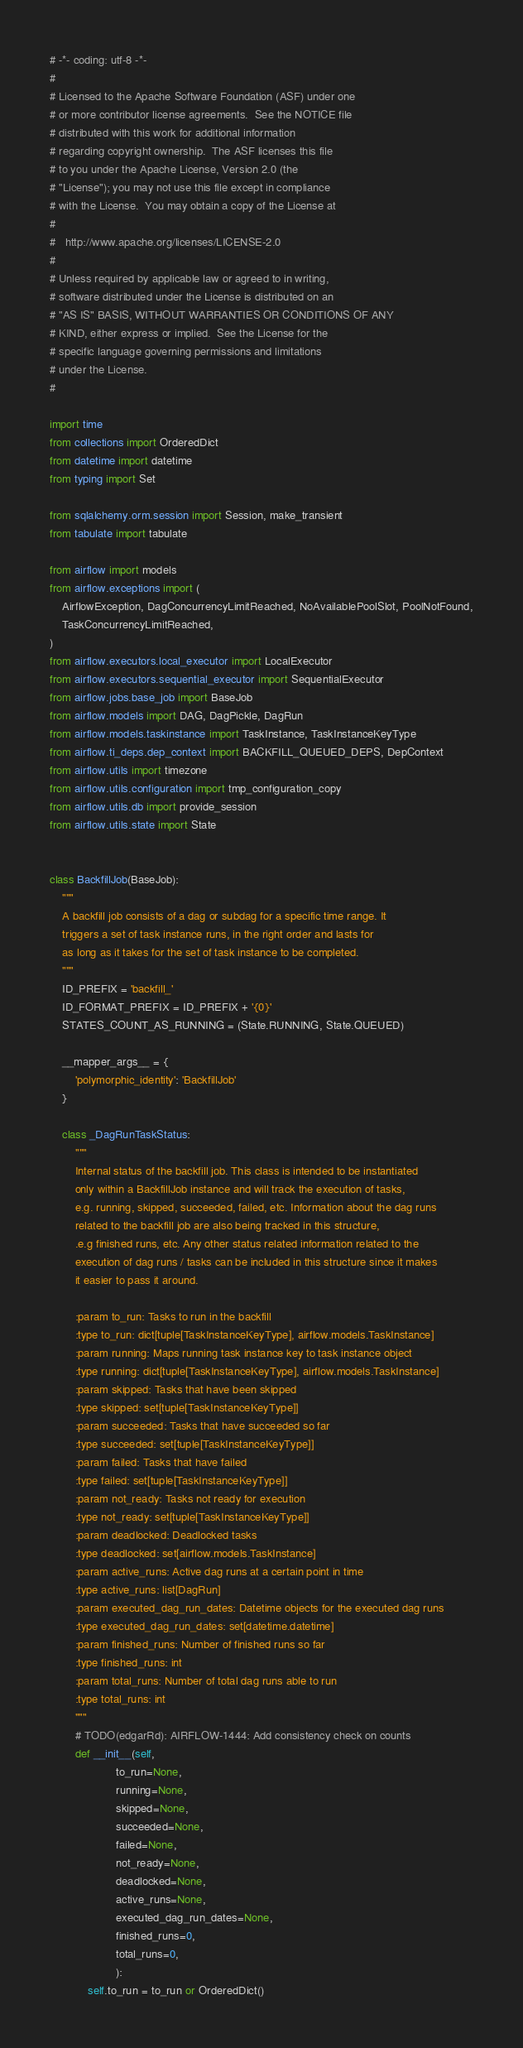Convert code to text. <code><loc_0><loc_0><loc_500><loc_500><_Python_># -*- coding: utf-8 -*-
#
# Licensed to the Apache Software Foundation (ASF) under one
# or more contributor license agreements.  See the NOTICE file
# distributed with this work for additional information
# regarding copyright ownership.  The ASF licenses this file
# to you under the Apache License, Version 2.0 (the
# "License"); you may not use this file except in compliance
# with the License.  You may obtain a copy of the License at
#
#   http://www.apache.org/licenses/LICENSE-2.0
#
# Unless required by applicable law or agreed to in writing,
# software distributed under the License is distributed on an
# "AS IS" BASIS, WITHOUT WARRANTIES OR CONDITIONS OF ANY
# KIND, either express or implied.  See the License for the
# specific language governing permissions and limitations
# under the License.
#

import time
from collections import OrderedDict
from datetime import datetime
from typing import Set

from sqlalchemy.orm.session import Session, make_transient
from tabulate import tabulate

from airflow import models
from airflow.exceptions import (
    AirflowException, DagConcurrencyLimitReached, NoAvailablePoolSlot, PoolNotFound,
    TaskConcurrencyLimitReached,
)
from airflow.executors.local_executor import LocalExecutor
from airflow.executors.sequential_executor import SequentialExecutor
from airflow.jobs.base_job import BaseJob
from airflow.models import DAG, DagPickle, DagRun
from airflow.models.taskinstance import TaskInstance, TaskInstanceKeyType
from airflow.ti_deps.dep_context import BACKFILL_QUEUED_DEPS, DepContext
from airflow.utils import timezone
from airflow.utils.configuration import tmp_configuration_copy
from airflow.utils.db import provide_session
from airflow.utils.state import State


class BackfillJob(BaseJob):
    """
    A backfill job consists of a dag or subdag for a specific time range. It
    triggers a set of task instance runs, in the right order and lasts for
    as long as it takes for the set of task instance to be completed.
    """
    ID_PREFIX = 'backfill_'
    ID_FORMAT_PREFIX = ID_PREFIX + '{0}'
    STATES_COUNT_AS_RUNNING = (State.RUNNING, State.QUEUED)

    __mapper_args__ = {
        'polymorphic_identity': 'BackfillJob'
    }

    class _DagRunTaskStatus:
        """
        Internal status of the backfill job. This class is intended to be instantiated
        only within a BackfillJob instance and will track the execution of tasks,
        e.g. running, skipped, succeeded, failed, etc. Information about the dag runs
        related to the backfill job are also being tracked in this structure,
        .e.g finished runs, etc. Any other status related information related to the
        execution of dag runs / tasks can be included in this structure since it makes
        it easier to pass it around.

        :param to_run: Tasks to run in the backfill
        :type to_run: dict[tuple[TaskInstanceKeyType], airflow.models.TaskInstance]
        :param running: Maps running task instance key to task instance object
        :type running: dict[tuple[TaskInstanceKeyType], airflow.models.TaskInstance]
        :param skipped: Tasks that have been skipped
        :type skipped: set[tuple[TaskInstanceKeyType]]
        :param succeeded: Tasks that have succeeded so far
        :type succeeded: set[tuple[TaskInstanceKeyType]]
        :param failed: Tasks that have failed
        :type failed: set[tuple[TaskInstanceKeyType]]
        :param not_ready: Tasks not ready for execution
        :type not_ready: set[tuple[TaskInstanceKeyType]]
        :param deadlocked: Deadlocked tasks
        :type deadlocked: set[airflow.models.TaskInstance]
        :param active_runs: Active dag runs at a certain point in time
        :type active_runs: list[DagRun]
        :param executed_dag_run_dates: Datetime objects for the executed dag runs
        :type executed_dag_run_dates: set[datetime.datetime]
        :param finished_runs: Number of finished runs so far
        :type finished_runs: int
        :param total_runs: Number of total dag runs able to run
        :type total_runs: int
        """
        # TODO(edgarRd): AIRFLOW-1444: Add consistency check on counts
        def __init__(self,
                     to_run=None,
                     running=None,
                     skipped=None,
                     succeeded=None,
                     failed=None,
                     not_ready=None,
                     deadlocked=None,
                     active_runs=None,
                     executed_dag_run_dates=None,
                     finished_runs=0,
                     total_runs=0,
                     ):
            self.to_run = to_run or OrderedDict()</code> 